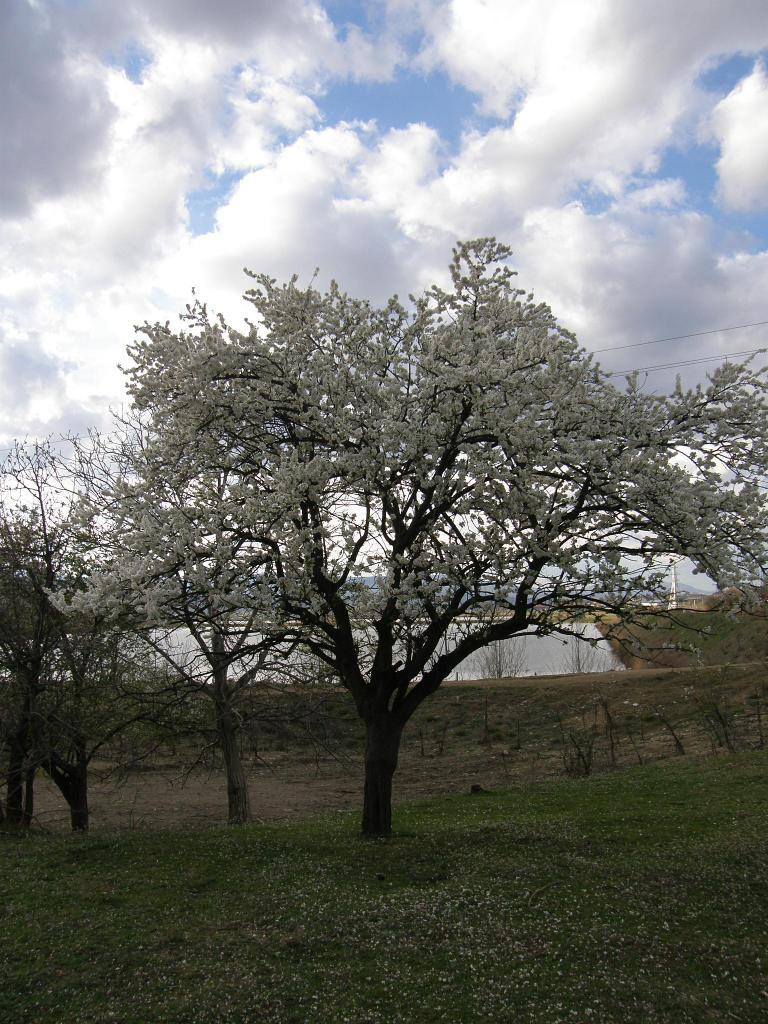What color are the flowers in the image? The flowers in the image are white in color. What other natural elements can be seen in the image? There are trees in green color in the image. What can be seen in the background of the image? There are poles in the background of the image. What is the color of the sky in the image? The sky is blue and white in color. Who is the uncle mentioned in the image? There is no mention of an uncle in the image. What type of cloth is draped over the flowers in the image? There is no cloth draped over the flowers in the image; the flowers are visible in their natural state. 